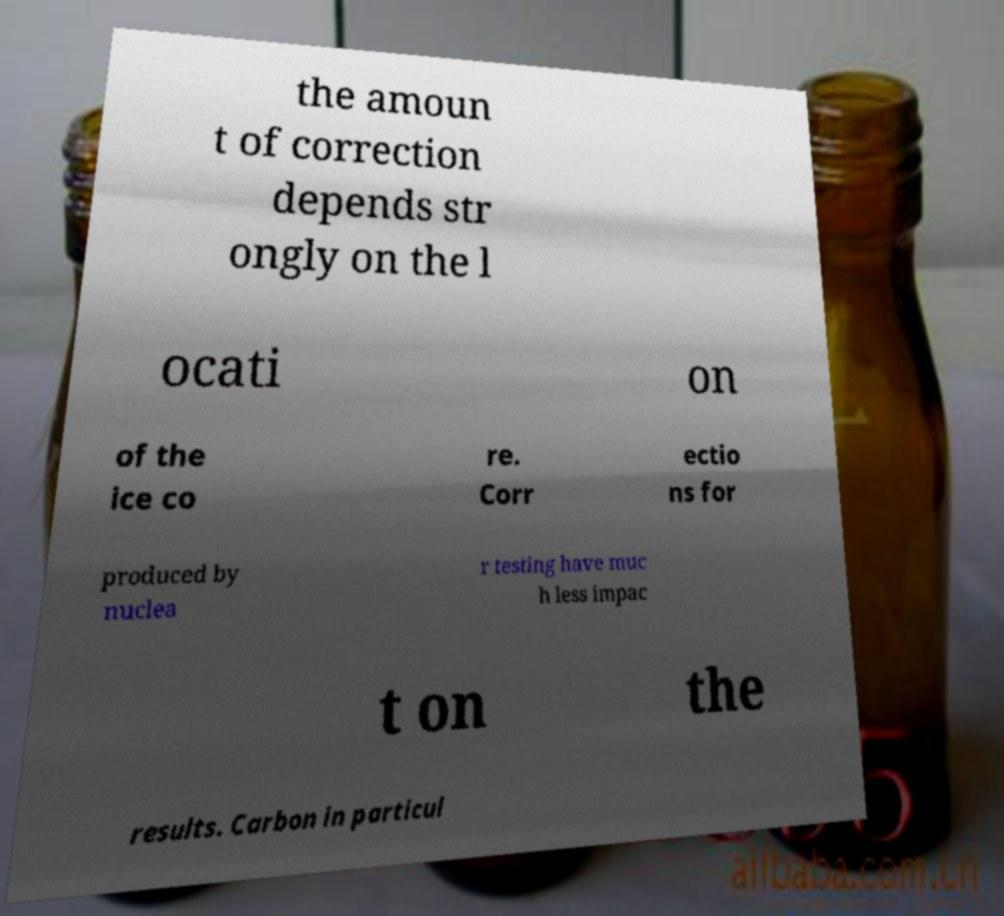There's text embedded in this image that I need extracted. Can you transcribe it verbatim? the amoun t of correction depends str ongly on the l ocati on of the ice co re. Corr ectio ns for produced by nuclea r testing have muc h less impac t on the results. Carbon in particul 